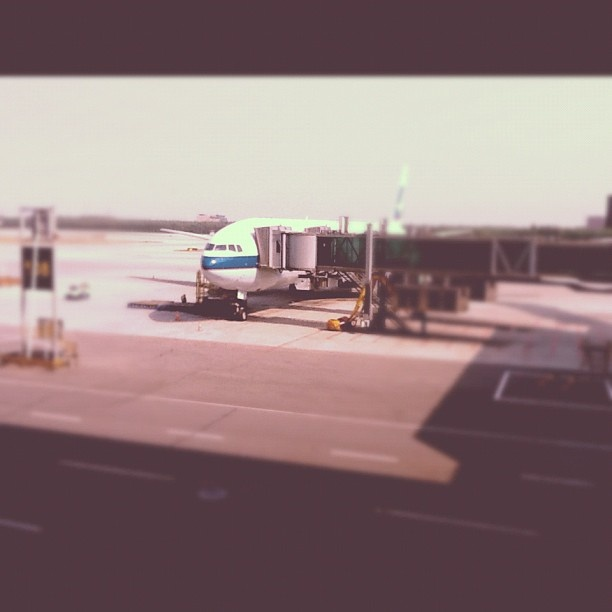Describe the objects in this image and their specific colors. I can see a airplane in purple, beige, darkgray, pink, and gray tones in this image. 